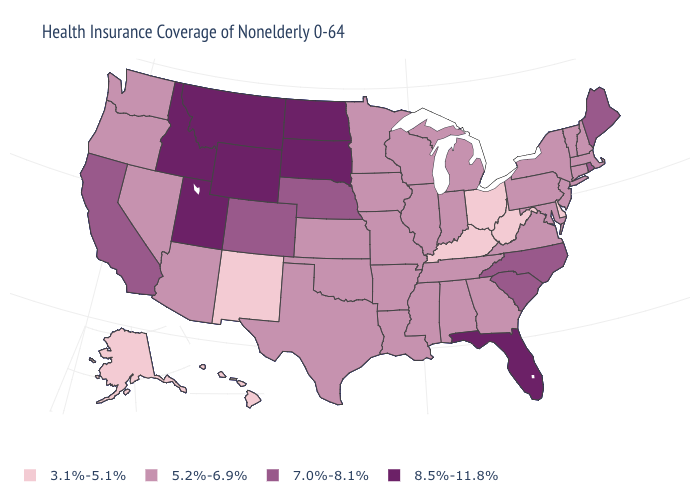Does New Hampshire have a lower value than Georgia?
Short answer required. No. Name the states that have a value in the range 8.5%-11.8%?
Answer briefly. Florida, Idaho, Montana, North Dakota, South Dakota, Utah, Wyoming. Does New York have the same value as Minnesota?
Write a very short answer. Yes. Name the states that have a value in the range 7.0%-8.1%?
Short answer required. California, Colorado, Maine, Nebraska, North Carolina, Rhode Island, South Carolina. Which states have the lowest value in the USA?
Quick response, please. Alaska, Delaware, Hawaii, Kentucky, New Mexico, Ohio, West Virginia. Does the map have missing data?
Short answer required. No. Name the states that have a value in the range 5.2%-6.9%?
Answer briefly. Alabama, Arizona, Arkansas, Connecticut, Georgia, Illinois, Indiana, Iowa, Kansas, Louisiana, Maryland, Massachusetts, Michigan, Minnesota, Mississippi, Missouri, Nevada, New Hampshire, New Jersey, New York, Oklahoma, Oregon, Pennsylvania, Tennessee, Texas, Vermont, Virginia, Washington, Wisconsin. What is the highest value in states that border Michigan?
Answer briefly. 5.2%-6.9%. What is the value of Arkansas?
Answer briefly. 5.2%-6.9%. What is the highest value in states that border California?
Give a very brief answer. 5.2%-6.9%. What is the value of Idaho?
Keep it brief. 8.5%-11.8%. Which states have the lowest value in the USA?
Be succinct. Alaska, Delaware, Hawaii, Kentucky, New Mexico, Ohio, West Virginia. What is the lowest value in states that border Nevada?
Be succinct. 5.2%-6.9%. Is the legend a continuous bar?
Write a very short answer. No. Which states have the lowest value in the MidWest?
Concise answer only. Ohio. 